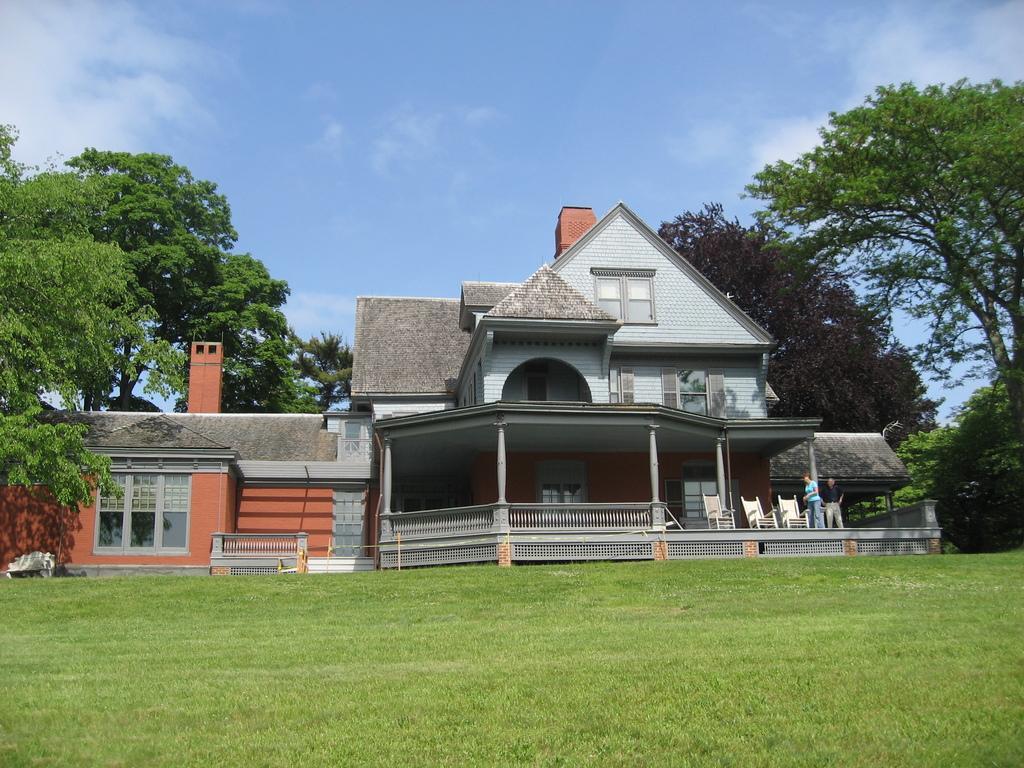Describe this image in one or two sentences. In this image, we can see a bungalow with pillars, walls, glass windows, railings. Right side of the image, we can see few chairs, peoples. At the bottom, there is a grass. Background we can see so many trees. Top of the image, there is a sky. 